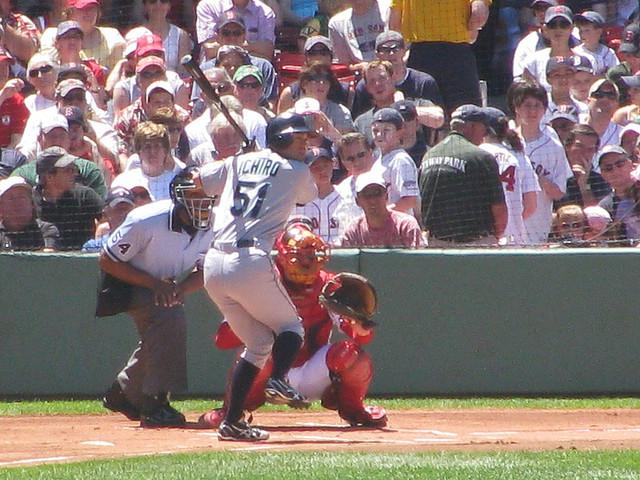What is the net in front of the spectators there for?

Choices:
A) stop ball
B) chicken pen
C) player captivity
D) punishment stop ball 